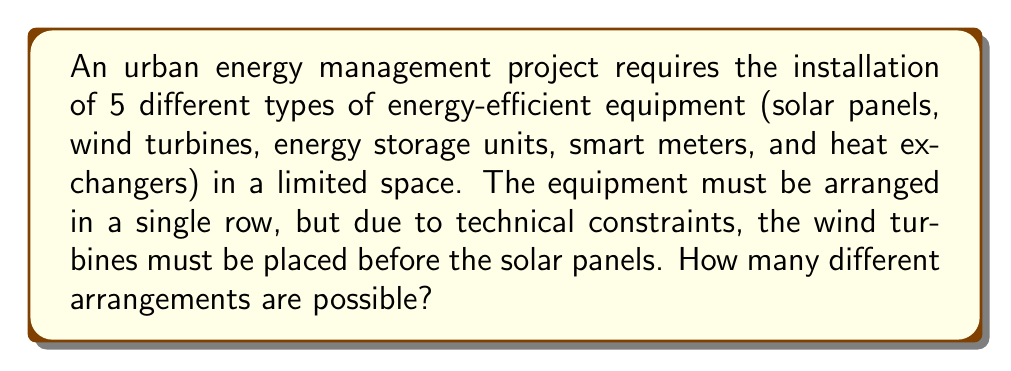Help me with this question. Let's approach this step-by-step:

1) First, we need to consider the constraint that wind turbines must be placed before solar panels. We can treat these two pieces of equipment as a single unit, with wind turbines always preceding solar panels.

2) Now, we effectively have 4 units to arrange:
   - Wind turbine + Solar panel (treated as one unit)
   - Energy storage units
   - Smart meters
   - Heat exchangers

3) The number of ways to arrange 4 distinct objects is given by the permutation formula:

   $P(4,4) = 4! = 4 \times 3 \times 2 \times 1 = 24$

4) However, we're not done yet. For each of these 24 arrangements, we need to consider the possible arrangements of the wind turbine and solar panel within their unit.

5) There are 2! = 2 ways to arrange the wind turbine and solar panel within their unit, but we're told that the wind turbine must come first. So there's only 1 way to arrange these two.

6) Therefore, the total number of possible arrangements is:

   $24 \times 1 = 24$

Thus, there are 24 different possible arrangements of the equipment.
Answer: 24 